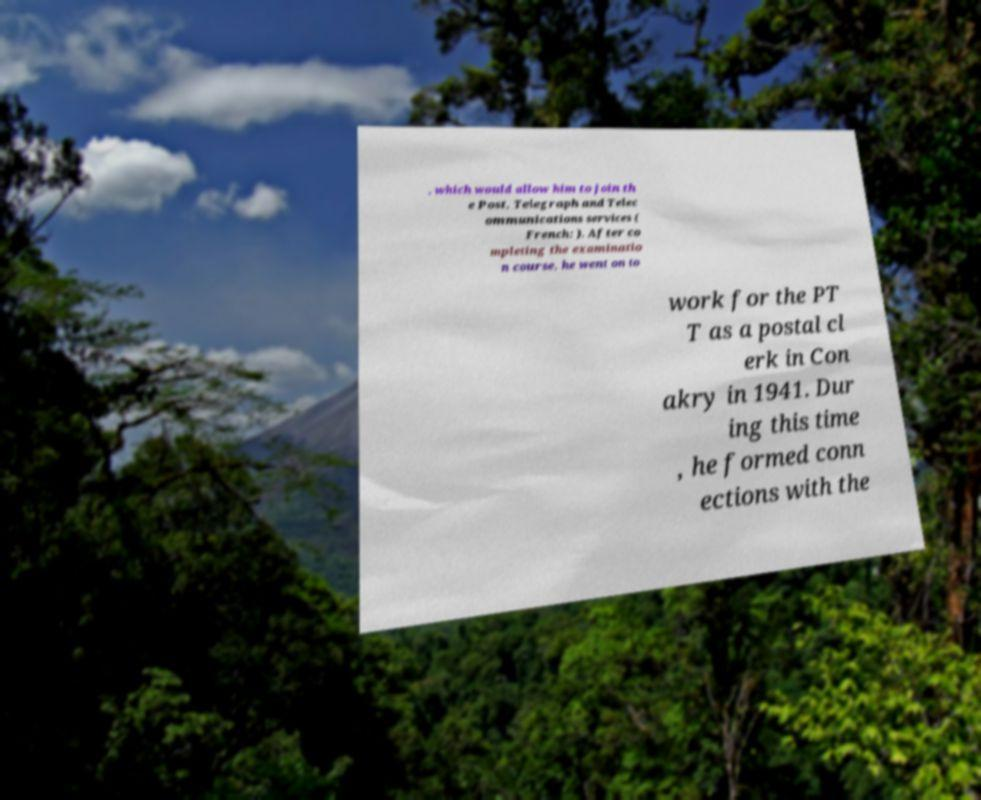For documentation purposes, I need the text within this image transcribed. Could you provide that? , which would allow him to join th e Post, Telegraph and Telec ommunications services ( French: ). After co mpleting the examinatio n course, he went on to work for the PT T as a postal cl erk in Con akry in 1941. Dur ing this time , he formed conn ections with the 